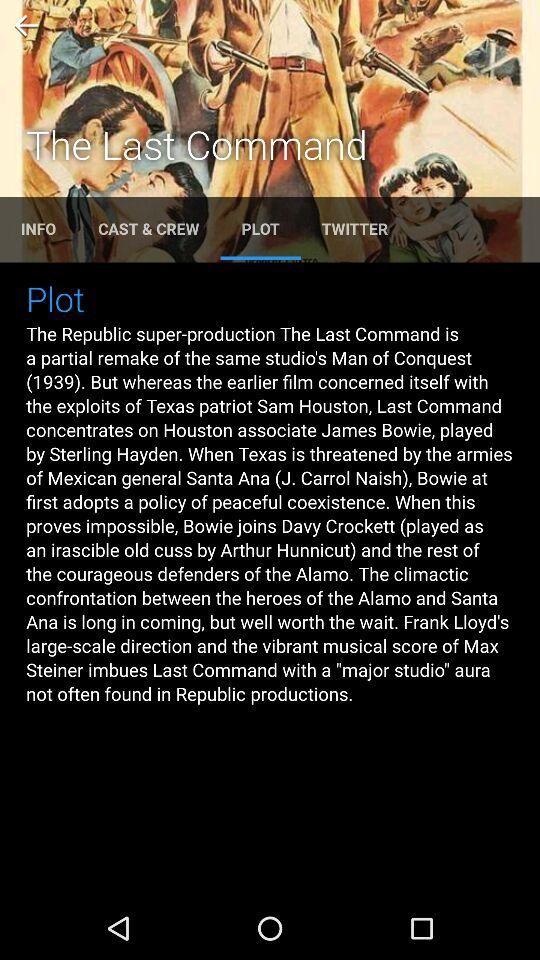Which tab is currently selected? The selected tab is "PLOT". 